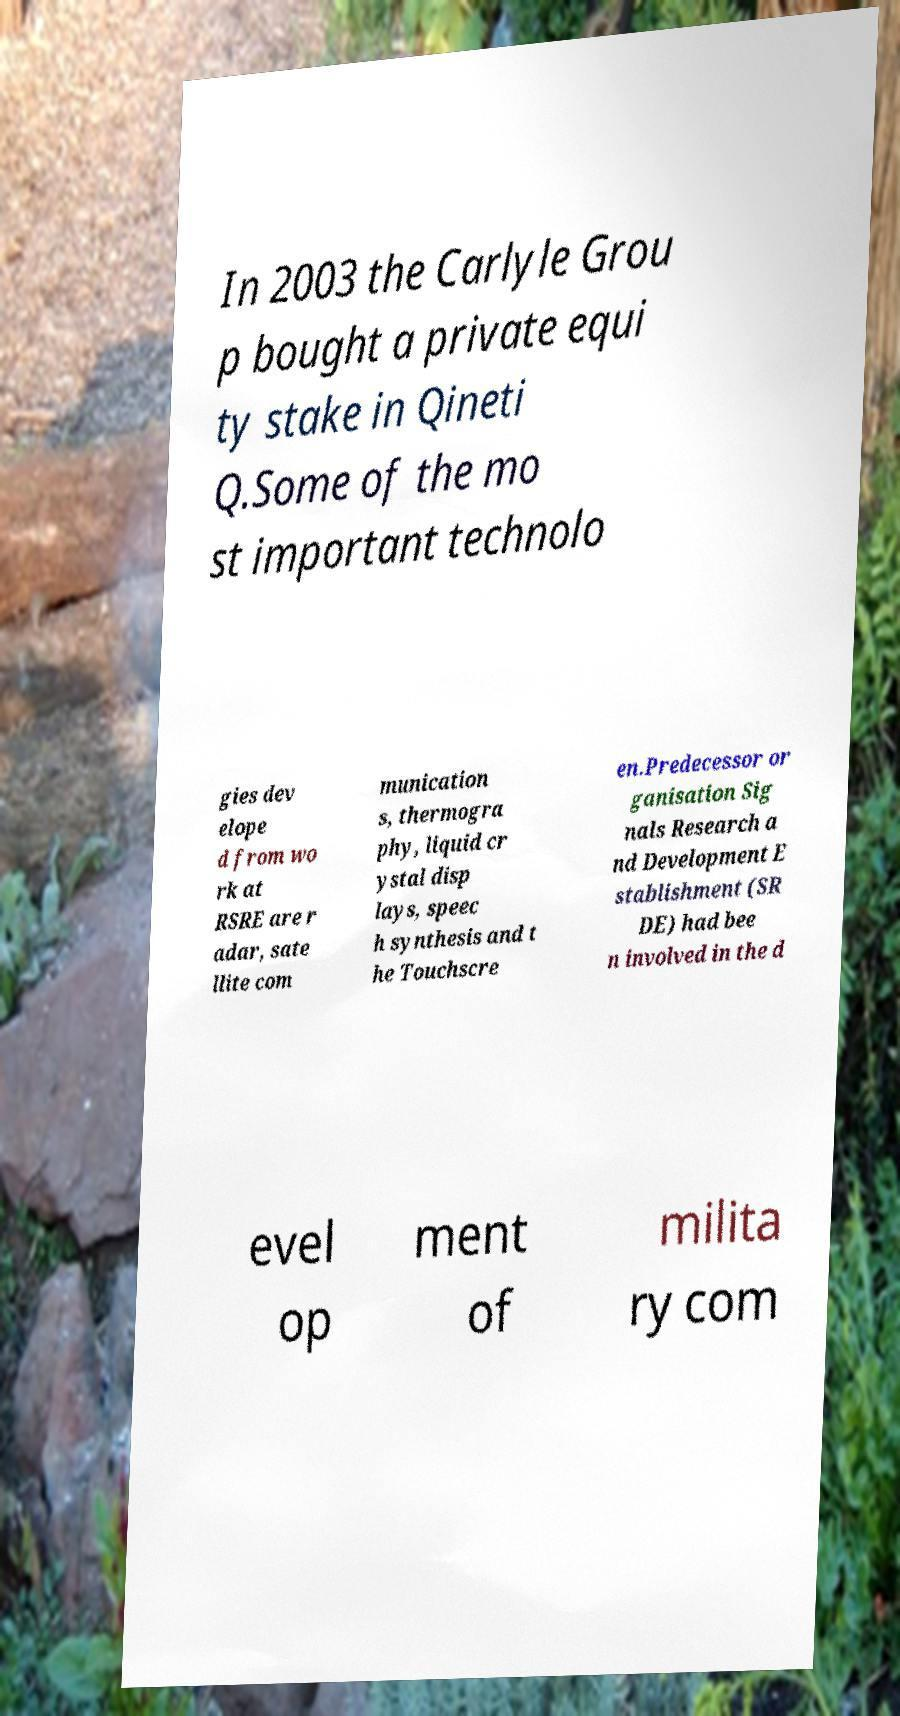I need the written content from this picture converted into text. Can you do that? In 2003 the Carlyle Grou p bought a private equi ty stake in Qineti Q.Some of the mo st important technolo gies dev elope d from wo rk at RSRE are r adar, sate llite com munication s, thermogra phy, liquid cr ystal disp lays, speec h synthesis and t he Touchscre en.Predecessor or ganisation Sig nals Research a nd Development E stablishment (SR DE) had bee n involved in the d evel op ment of milita ry com 